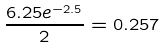<formula> <loc_0><loc_0><loc_500><loc_500>\frac { 6 . 2 5 e ^ { - 2 . 5 } } { 2 } = 0 . 2 5 7</formula> 